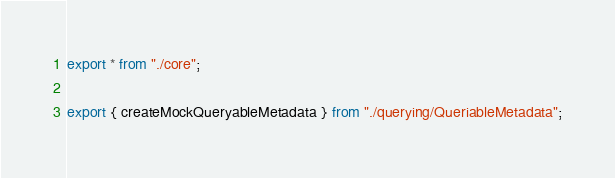<code> <loc_0><loc_0><loc_500><loc_500><_TypeScript_>export * from "./core";

export { createMockQueryableMetadata } from "./querying/QueriableMetadata";

</code> 